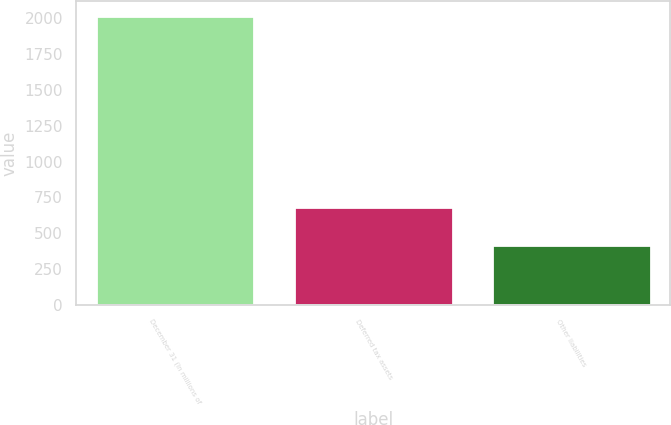<chart> <loc_0><loc_0><loc_500><loc_500><bar_chart><fcel>December 31 (In millions of<fcel>Deferred tax assets<fcel>Other liabilities<nl><fcel>2018<fcel>680<fcel>421<nl></chart> 